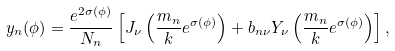Convert formula to latex. <formula><loc_0><loc_0><loc_500><loc_500>y _ { n } ( \phi ) = \frac { e ^ { 2 \sigma ( \phi ) } } { N _ { n } } \left [ J _ { \nu } \left ( { \frac { m _ { n } } { k } } e ^ { \sigma ( \phi ) } \right ) + b _ { n \nu } Y _ { \nu } \left ( { \frac { m _ { n } } { k } } e ^ { \sigma ( \phi ) } \right ) \right ] ,</formula> 